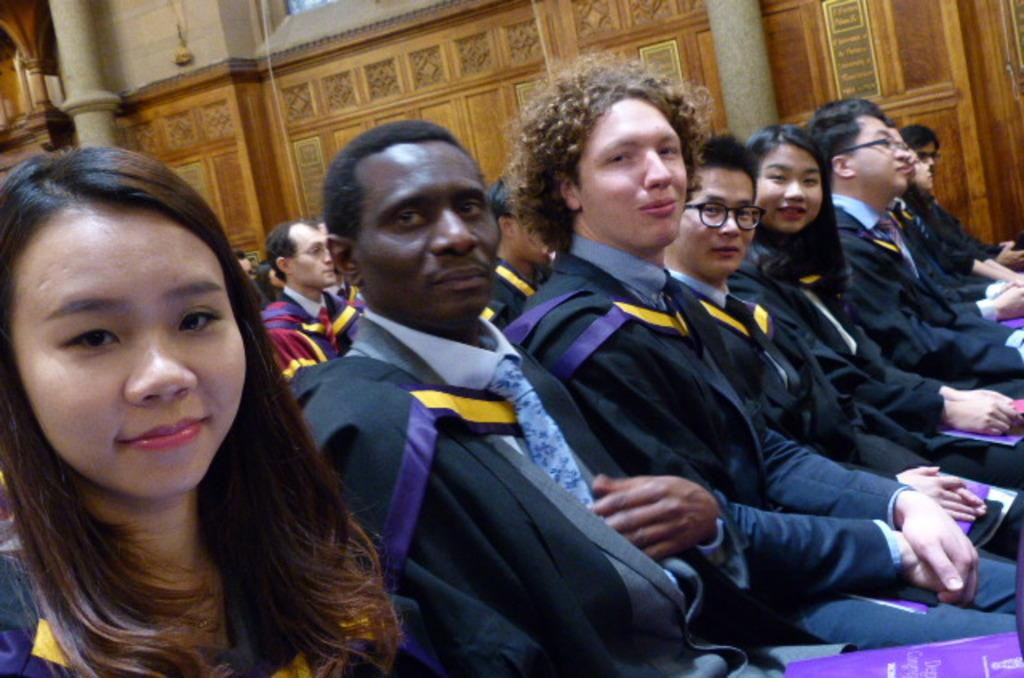How many people are in the image? There are many people in the image. What are the people doing in the image? The people are sitting on chairs. What are the people wearing in the image? The people are wearing graduation dress. What can be seen in the background of the image? There is a wall in the background of the image. Are there any pins visible on the graduation dresses in the image? There is no mention of pins on the graduation dresses in the provided facts, so we cannot determine their presence from the image. 